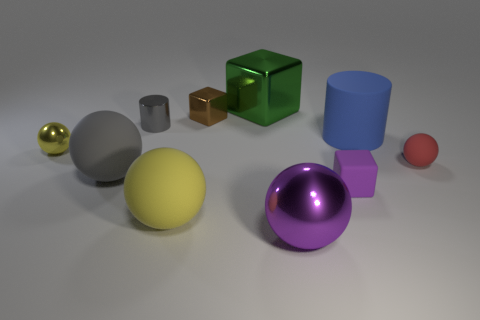Subtract all yellow balls. How many were subtracted if there are1yellow balls left? 1 Subtract all small balls. How many balls are left? 3 Subtract all gray balls. How many balls are left? 4 Subtract all red cubes. How many yellow balls are left? 2 Subtract 3 balls. How many balls are left? 2 Subtract all cubes. How many objects are left? 7 Subtract all red cubes. Subtract all blue cylinders. How many cubes are left? 3 Subtract 0 green cylinders. How many objects are left? 10 Subtract all big matte spheres. Subtract all balls. How many objects are left? 3 Add 4 gray metal objects. How many gray metal objects are left? 5 